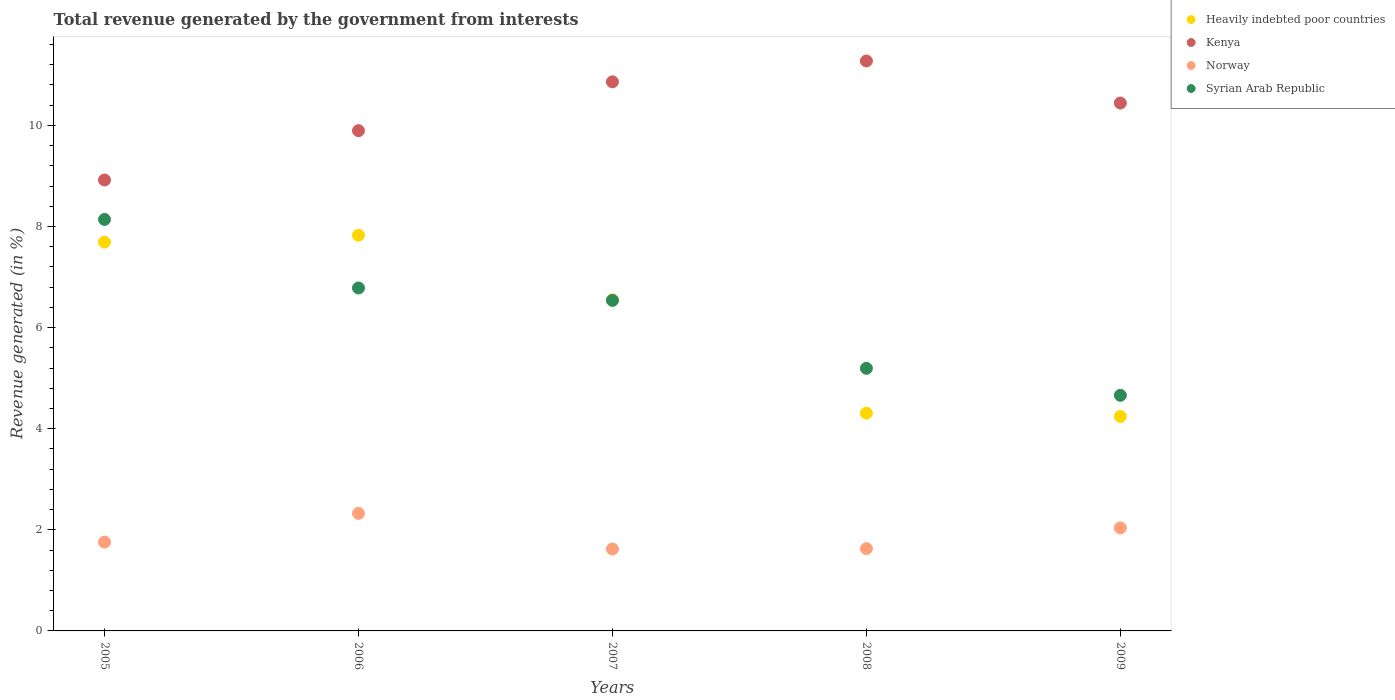How many different coloured dotlines are there?
Your response must be concise. 4. Is the number of dotlines equal to the number of legend labels?
Offer a very short reply. Yes. What is the total revenue generated in Norway in 2005?
Provide a short and direct response. 1.76. Across all years, what is the maximum total revenue generated in Heavily indebted poor countries?
Provide a succinct answer. 7.83. Across all years, what is the minimum total revenue generated in Kenya?
Your response must be concise. 8.92. What is the total total revenue generated in Kenya in the graph?
Keep it short and to the point. 51.39. What is the difference between the total revenue generated in Heavily indebted poor countries in 2007 and that in 2009?
Provide a succinct answer. 2.31. What is the difference between the total revenue generated in Syrian Arab Republic in 2005 and the total revenue generated in Norway in 2007?
Your response must be concise. 6.52. What is the average total revenue generated in Kenya per year?
Keep it short and to the point. 10.28. In the year 2009, what is the difference between the total revenue generated in Syrian Arab Republic and total revenue generated in Heavily indebted poor countries?
Make the answer very short. 0.42. What is the ratio of the total revenue generated in Kenya in 2008 to that in 2009?
Your answer should be very brief. 1.08. What is the difference between the highest and the second highest total revenue generated in Norway?
Offer a very short reply. 0.29. What is the difference between the highest and the lowest total revenue generated in Heavily indebted poor countries?
Provide a short and direct response. 3.59. Is it the case that in every year, the sum of the total revenue generated in Norway and total revenue generated in Syrian Arab Republic  is greater than the sum of total revenue generated in Kenya and total revenue generated in Heavily indebted poor countries?
Offer a terse response. No. Is it the case that in every year, the sum of the total revenue generated in Norway and total revenue generated in Kenya  is greater than the total revenue generated in Heavily indebted poor countries?
Your answer should be very brief. Yes. Is the total revenue generated in Heavily indebted poor countries strictly less than the total revenue generated in Kenya over the years?
Keep it short and to the point. Yes. How many years are there in the graph?
Your response must be concise. 5. What is the difference between two consecutive major ticks on the Y-axis?
Offer a terse response. 2. Does the graph contain any zero values?
Ensure brevity in your answer.  No. Does the graph contain grids?
Your answer should be compact. No. How many legend labels are there?
Ensure brevity in your answer.  4. What is the title of the graph?
Offer a terse response. Total revenue generated by the government from interests. Does "Algeria" appear as one of the legend labels in the graph?
Keep it short and to the point. No. What is the label or title of the Y-axis?
Provide a short and direct response. Revenue generated (in %). What is the Revenue generated (in %) of Heavily indebted poor countries in 2005?
Your answer should be very brief. 7.69. What is the Revenue generated (in %) in Kenya in 2005?
Offer a very short reply. 8.92. What is the Revenue generated (in %) of Norway in 2005?
Your answer should be compact. 1.76. What is the Revenue generated (in %) of Syrian Arab Republic in 2005?
Your answer should be compact. 8.14. What is the Revenue generated (in %) of Heavily indebted poor countries in 2006?
Offer a terse response. 7.83. What is the Revenue generated (in %) in Kenya in 2006?
Keep it short and to the point. 9.9. What is the Revenue generated (in %) of Norway in 2006?
Offer a very short reply. 2.32. What is the Revenue generated (in %) of Syrian Arab Republic in 2006?
Make the answer very short. 6.78. What is the Revenue generated (in %) of Heavily indebted poor countries in 2007?
Offer a terse response. 6.55. What is the Revenue generated (in %) of Kenya in 2007?
Make the answer very short. 10.86. What is the Revenue generated (in %) in Norway in 2007?
Ensure brevity in your answer.  1.62. What is the Revenue generated (in %) of Syrian Arab Republic in 2007?
Keep it short and to the point. 6.54. What is the Revenue generated (in %) of Heavily indebted poor countries in 2008?
Make the answer very short. 4.31. What is the Revenue generated (in %) in Kenya in 2008?
Give a very brief answer. 11.27. What is the Revenue generated (in %) of Norway in 2008?
Offer a terse response. 1.63. What is the Revenue generated (in %) in Syrian Arab Republic in 2008?
Provide a succinct answer. 5.19. What is the Revenue generated (in %) of Heavily indebted poor countries in 2009?
Provide a succinct answer. 4.24. What is the Revenue generated (in %) in Kenya in 2009?
Your response must be concise. 10.44. What is the Revenue generated (in %) in Norway in 2009?
Keep it short and to the point. 2.04. What is the Revenue generated (in %) of Syrian Arab Republic in 2009?
Keep it short and to the point. 4.66. Across all years, what is the maximum Revenue generated (in %) in Heavily indebted poor countries?
Your response must be concise. 7.83. Across all years, what is the maximum Revenue generated (in %) of Kenya?
Make the answer very short. 11.27. Across all years, what is the maximum Revenue generated (in %) of Norway?
Your answer should be compact. 2.32. Across all years, what is the maximum Revenue generated (in %) of Syrian Arab Republic?
Provide a succinct answer. 8.14. Across all years, what is the minimum Revenue generated (in %) of Heavily indebted poor countries?
Offer a terse response. 4.24. Across all years, what is the minimum Revenue generated (in %) in Kenya?
Provide a succinct answer. 8.92. Across all years, what is the minimum Revenue generated (in %) of Norway?
Make the answer very short. 1.62. Across all years, what is the minimum Revenue generated (in %) in Syrian Arab Republic?
Provide a succinct answer. 4.66. What is the total Revenue generated (in %) of Heavily indebted poor countries in the graph?
Your answer should be very brief. 30.62. What is the total Revenue generated (in %) in Kenya in the graph?
Provide a short and direct response. 51.39. What is the total Revenue generated (in %) in Norway in the graph?
Offer a terse response. 9.37. What is the total Revenue generated (in %) of Syrian Arab Republic in the graph?
Ensure brevity in your answer.  31.32. What is the difference between the Revenue generated (in %) of Heavily indebted poor countries in 2005 and that in 2006?
Provide a short and direct response. -0.14. What is the difference between the Revenue generated (in %) in Kenya in 2005 and that in 2006?
Give a very brief answer. -0.98. What is the difference between the Revenue generated (in %) of Norway in 2005 and that in 2006?
Offer a very short reply. -0.57. What is the difference between the Revenue generated (in %) of Syrian Arab Republic in 2005 and that in 2006?
Provide a succinct answer. 1.36. What is the difference between the Revenue generated (in %) of Heavily indebted poor countries in 2005 and that in 2007?
Your answer should be very brief. 1.14. What is the difference between the Revenue generated (in %) of Kenya in 2005 and that in 2007?
Keep it short and to the point. -1.94. What is the difference between the Revenue generated (in %) of Norway in 2005 and that in 2007?
Your answer should be very brief. 0.14. What is the difference between the Revenue generated (in %) of Syrian Arab Republic in 2005 and that in 2007?
Your answer should be very brief. 1.6. What is the difference between the Revenue generated (in %) of Heavily indebted poor countries in 2005 and that in 2008?
Your response must be concise. 3.38. What is the difference between the Revenue generated (in %) in Kenya in 2005 and that in 2008?
Your answer should be compact. -2.35. What is the difference between the Revenue generated (in %) of Norway in 2005 and that in 2008?
Keep it short and to the point. 0.13. What is the difference between the Revenue generated (in %) in Syrian Arab Republic in 2005 and that in 2008?
Give a very brief answer. 2.94. What is the difference between the Revenue generated (in %) of Heavily indebted poor countries in 2005 and that in 2009?
Your answer should be very brief. 3.45. What is the difference between the Revenue generated (in %) of Kenya in 2005 and that in 2009?
Provide a short and direct response. -1.52. What is the difference between the Revenue generated (in %) of Norway in 2005 and that in 2009?
Offer a terse response. -0.28. What is the difference between the Revenue generated (in %) in Syrian Arab Republic in 2005 and that in 2009?
Your answer should be very brief. 3.48. What is the difference between the Revenue generated (in %) in Heavily indebted poor countries in 2006 and that in 2007?
Your answer should be compact. 1.28. What is the difference between the Revenue generated (in %) in Kenya in 2006 and that in 2007?
Give a very brief answer. -0.97. What is the difference between the Revenue generated (in %) in Norway in 2006 and that in 2007?
Give a very brief answer. 0.7. What is the difference between the Revenue generated (in %) of Syrian Arab Republic in 2006 and that in 2007?
Provide a succinct answer. 0.25. What is the difference between the Revenue generated (in %) of Heavily indebted poor countries in 2006 and that in 2008?
Your response must be concise. 3.52. What is the difference between the Revenue generated (in %) of Kenya in 2006 and that in 2008?
Give a very brief answer. -1.38. What is the difference between the Revenue generated (in %) in Norway in 2006 and that in 2008?
Give a very brief answer. 0.7. What is the difference between the Revenue generated (in %) in Syrian Arab Republic in 2006 and that in 2008?
Your response must be concise. 1.59. What is the difference between the Revenue generated (in %) in Heavily indebted poor countries in 2006 and that in 2009?
Offer a terse response. 3.59. What is the difference between the Revenue generated (in %) of Kenya in 2006 and that in 2009?
Provide a short and direct response. -0.55. What is the difference between the Revenue generated (in %) in Norway in 2006 and that in 2009?
Give a very brief answer. 0.29. What is the difference between the Revenue generated (in %) in Syrian Arab Republic in 2006 and that in 2009?
Your answer should be compact. 2.12. What is the difference between the Revenue generated (in %) in Heavily indebted poor countries in 2007 and that in 2008?
Provide a succinct answer. 2.24. What is the difference between the Revenue generated (in %) of Kenya in 2007 and that in 2008?
Offer a very short reply. -0.41. What is the difference between the Revenue generated (in %) of Norway in 2007 and that in 2008?
Provide a short and direct response. -0.01. What is the difference between the Revenue generated (in %) in Syrian Arab Republic in 2007 and that in 2008?
Ensure brevity in your answer.  1.34. What is the difference between the Revenue generated (in %) of Heavily indebted poor countries in 2007 and that in 2009?
Give a very brief answer. 2.31. What is the difference between the Revenue generated (in %) of Kenya in 2007 and that in 2009?
Your answer should be compact. 0.42. What is the difference between the Revenue generated (in %) of Norway in 2007 and that in 2009?
Your response must be concise. -0.42. What is the difference between the Revenue generated (in %) in Syrian Arab Republic in 2007 and that in 2009?
Offer a very short reply. 1.88. What is the difference between the Revenue generated (in %) of Heavily indebted poor countries in 2008 and that in 2009?
Ensure brevity in your answer.  0.07. What is the difference between the Revenue generated (in %) of Kenya in 2008 and that in 2009?
Offer a terse response. 0.83. What is the difference between the Revenue generated (in %) in Norway in 2008 and that in 2009?
Offer a terse response. -0.41. What is the difference between the Revenue generated (in %) of Syrian Arab Republic in 2008 and that in 2009?
Offer a very short reply. 0.53. What is the difference between the Revenue generated (in %) in Heavily indebted poor countries in 2005 and the Revenue generated (in %) in Kenya in 2006?
Your answer should be compact. -2.2. What is the difference between the Revenue generated (in %) of Heavily indebted poor countries in 2005 and the Revenue generated (in %) of Norway in 2006?
Offer a terse response. 5.37. What is the difference between the Revenue generated (in %) in Heavily indebted poor countries in 2005 and the Revenue generated (in %) in Syrian Arab Republic in 2006?
Offer a terse response. 0.91. What is the difference between the Revenue generated (in %) of Kenya in 2005 and the Revenue generated (in %) of Norway in 2006?
Provide a succinct answer. 6.59. What is the difference between the Revenue generated (in %) of Kenya in 2005 and the Revenue generated (in %) of Syrian Arab Republic in 2006?
Provide a short and direct response. 2.14. What is the difference between the Revenue generated (in %) of Norway in 2005 and the Revenue generated (in %) of Syrian Arab Republic in 2006?
Give a very brief answer. -5.03. What is the difference between the Revenue generated (in %) in Heavily indebted poor countries in 2005 and the Revenue generated (in %) in Kenya in 2007?
Ensure brevity in your answer.  -3.17. What is the difference between the Revenue generated (in %) in Heavily indebted poor countries in 2005 and the Revenue generated (in %) in Norway in 2007?
Provide a short and direct response. 6.07. What is the difference between the Revenue generated (in %) of Heavily indebted poor countries in 2005 and the Revenue generated (in %) of Syrian Arab Republic in 2007?
Ensure brevity in your answer.  1.15. What is the difference between the Revenue generated (in %) in Kenya in 2005 and the Revenue generated (in %) in Norway in 2007?
Give a very brief answer. 7.3. What is the difference between the Revenue generated (in %) of Kenya in 2005 and the Revenue generated (in %) of Syrian Arab Republic in 2007?
Give a very brief answer. 2.38. What is the difference between the Revenue generated (in %) in Norway in 2005 and the Revenue generated (in %) in Syrian Arab Republic in 2007?
Offer a terse response. -4.78. What is the difference between the Revenue generated (in %) of Heavily indebted poor countries in 2005 and the Revenue generated (in %) of Kenya in 2008?
Keep it short and to the point. -3.58. What is the difference between the Revenue generated (in %) of Heavily indebted poor countries in 2005 and the Revenue generated (in %) of Norway in 2008?
Your answer should be very brief. 6.06. What is the difference between the Revenue generated (in %) of Heavily indebted poor countries in 2005 and the Revenue generated (in %) of Syrian Arab Republic in 2008?
Offer a terse response. 2.5. What is the difference between the Revenue generated (in %) in Kenya in 2005 and the Revenue generated (in %) in Norway in 2008?
Give a very brief answer. 7.29. What is the difference between the Revenue generated (in %) of Kenya in 2005 and the Revenue generated (in %) of Syrian Arab Republic in 2008?
Offer a very short reply. 3.73. What is the difference between the Revenue generated (in %) in Norway in 2005 and the Revenue generated (in %) in Syrian Arab Republic in 2008?
Make the answer very short. -3.44. What is the difference between the Revenue generated (in %) in Heavily indebted poor countries in 2005 and the Revenue generated (in %) in Kenya in 2009?
Offer a terse response. -2.75. What is the difference between the Revenue generated (in %) in Heavily indebted poor countries in 2005 and the Revenue generated (in %) in Norway in 2009?
Your response must be concise. 5.65. What is the difference between the Revenue generated (in %) of Heavily indebted poor countries in 2005 and the Revenue generated (in %) of Syrian Arab Republic in 2009?
Offer a terse response. 3.03. What is the difference between the Revenue generated (in %) in Kenya in 2005 and the Revenue generated (in %) in Norway in 2009?
Your response must be concise. 6.88. What is the difference between the Revenue generated (in %) in Kenya in 2005 and the Revenue generated (in %) in Syrian Arab Republic in 2009?
Keep it short and to the point. 4.26. What is the difference between the Revenue generated (in %) in Norway in 2005 and the Revenue generated (in %) in Syrian Arab Republic in 2009?
Make the answer very short. -2.9. What is the difference between the Revenue generated (in %) in Heavily indebted poor countries in 2006 and the Revenue generated (in %) in Kenya in 2007?
Give a very brief answer. -3.03. What is the difference between the Revenue generated (in %) in Heavily indebted poor countries in 2006 and the Revenue generated (in %) in Norway in 2007?
Your response must be concise. 6.21. What is the difference between the Revenue generated (in %) of Heavily indebted poor countries in 2006 and the Revenue generated (in %) of Syrian Arab Republic in 2007?
Your answer should be very brief. 1.29. What is the difference between the Revenue generated (in %) in Kenya in 2006 and the Revenue generated (in %) in Norway in 2007?
Your answer should be very brief. 8.27. What is the difference between the Revenue generated (in %) in Kenya in 2006 and the Revenue generated (in %) in Syrian Arab Republic in 2007?
Give a very brief answer. 3.36. What is the difference between the Revenue generated (in %) in Norway in 2006 and the Revenue generated (in %) in Syrian Arab Republic in 2007?
Offer a terse response. -4.21. What is the difference between the Revenue generated (in %) of Heavily indebted poor countries in 2006 and the Revenue generated (in %) of Kenya in 2008?
Ensure brevity in your answer.  -3.45. What is the difference between the Revenue generated (in %) in Heavily indebted poor countries in 2006 and the Revenue generated (in %) in Norway in 2008?
Give a very brief answer. 6.2. What is the difference between the Revenue generated (in %) of Heavily indebted poor countries in 2006 and the Revenue generated (in %) of Syrian Arab Republic in 2008?
Give a very brief answer. 2.63. What is the difference between the Revenue generated (in %) in Kenya in 2006 and the Revenue generated (in %) in Norway in 2008?
Keep it short and to the point. 8.27. What is the difference between the Revenue generated (in %) of Kenya in 2006 and the Revenue generated (in %) of Syrian Arab Republic in 2008?
Keep it short and to the point. 4.7. What is the difference between the Revenue generated (in %) in Norway in 2006 and the Revenue generated (in %) in Syrian Arab Republic in 2008?
Offer a terse response. -2.87. What is the difference between the Revenue generated (in %) in Heavily indebted poor countries in 2006 and the Revenue generated (in %) in Kenya in 2009?
Your answer should be compact. -2.62. What is the difference between the Revenue generated (in %) of Heavily indebted poor countries in 2006 and the Revenue generated (in %) of Norway in 2009?
Offer a terse response. 5.79. What is the difference between the Revenue generated (in %) in Heavily indebted poor countries in 2006 and the Revenue generated (in %) in Syrian Arab Republic in 2009?
Offer a terse response. 3.17. What is the difference between the Revenue generated (in %) of Kenya in 2006 and the Revenue generated (in %) of Norway in 2009?
Offer a terse response. 7.86. What is the difference between the Revenue generated (in %) in Kenya in 2006 and the Revenue generated (in %) in Syrian Arab Republic in 2009?
Your answer should be very brief. 5.24. What is the difference between the Revenue generated (in %) in Norway in 2006 and the Revenue generated (in %) in Syrian Arab Republic in 2009?
Offer a very short reply. -2.34. What is the difference between the Revenue generated (in %) in Heavily indebted poor countries in 2007 and the Revenue generated (in %) in Kenya in 2008?
Provide a succinct answer. -4.73. What is the difference between the Revenue generated (in %) of Heavily indebted poor countries in 2007 and the Revenue generated (in %) of Norway in 2008?
Make the answer very short. 4.92. What is the difference between the Revenue generated (in %) of Heavily indebted poor countries in 2007 and the Revenue generated (in %) of Syrian Arab Republic in 2008?
Provide a succinct answer. 1.35. What is the difference between the Revenue generated (in %) in Kenya in 2007 and the Revenue generated (in %) in Norway in 2008?
Your answer should be very brief. 9.23. What is the difference between the Revenue generated (in %) of Kenya in 2007 and the Revenue generated (in %) of Syrian Arab Republic in 2008?
Give a very brief answer. 5.67. What is the difference between the Revenue generated (in %) of Norway in 2007 and the Revenue generated (in %) of Syrian Arab Republic in 2008?
Ensure brevity in your answer.  -3.57. What is the difference between the Revenue generated (in %) of Heavily indebted poor countries in 2007 and the Revenue generated (in %) of Kenya in 2009?
Your answer should be very brief. -3.89. What is the difference between the Revenue generated (in %) of Heavily indebted poor countries in 2007 and the Revenue generated (in %) of Norway in 2009?
Make the answer very short. 4.51. What is the difference between the Revenue generated (in %) of Heavily indebted poor countries in 2007 and the Revenue generated (in %) of Syrian Arab Republic in 2009?
Provide a succinct answer. 1.89. What is the difference between the Revenue generated (in %) of Kenya in 2007 and the Revenue generated (in %) of Norway in 2009?
Ensure brevity in your answer.  8.82. What is the difference between the Revenue generated (in %) in Kenya in 2007 and the Revenue generated (in %) in Syrian Arab Republic in 2009?
Keep it short and to the point. 6.2. What is the difference between the Revenue generated (in %) of Norway in 2007 and the Revenue generated (in %) of Syrian Arab Republic in 2009?
Offer a very short reply. -3.04. What is the difference between the Revenue generated (in %) in Heavily indebted poor countries in 2008 and the Revenue generated (in %) in Kenya in 2009?
Your answer should be very brief. -6.14. What is the difference between the Revenue generated (in %) of Heavily indebted poor countries in 2008 and the Revenue generated (in %) of Norway in 2009?
Make the answer very short. 2.27. What is the difference between the Revenue generated (in %) of Heavily indebted poor countries in 2008 and the Revenue generated (in %) of Syrian Arab Republic in 2009?
Your answer should be compact. -0.35. What is the difference between the Revenue generated (in %) in Kenya in 2008 and the Revenue generated (in %) in Norway in 2009?
Your answer should be compact. 9.24. What is the difference between the Revenue generated (in %) in Kenya in 2008 and the Revenue generated (in %) in Syrian Arab Republic in 2009?
Offer a terse response. 6.61. What is the difference between the Revenue generated (in %) in Norway in 2008 and the Revenue generated (in %) in Syrian Arab Republic in 2009?
Keep it short and to the point. -3.03. What is the average Revenue generated (in %) of Heavily indebted poor countries per year?
Give a very brief answer. 6.12. What is the average Revenue generated (in %) in Kenya per year?
Give a very brief answer. 10.28. What is the average Revenue generated (in %) in Norway per year?
Your answer should be very brief. 1.87. What is the average Revenue generated (in %) in Syrian Arab Republic per year?
Keep it short and to the point. 6.26. In the year 2005, what is the difference between the Revenue generated (in %) of Heavily indebted poor countries and Revenue generated (in %) of Kenya?
Make the answer very short. -1.23. In the year 2005, what is the difference between the Revenue generated (in %) of Heavily indebted poor countries and Revenue generated (in %) of Norway?
Your answer should be very brief. 5.93. In the year 2005, what is the difference between the Revenue generated (in %) of Heavily indebted poor countries and Revenue generated (in %) of Syrian Arab Republic?
Provide a short and direct response. -0.45. In the year 2005, what is the difference between the Revenue generated (in %) in Kenya and Revenue generated (in %) in Norway?
Offer a very short reply. 7.16. In the year 2005, what is the difference between the Revenue generated (in %) in Kenya and Revenue generated (in %) in Syrian Arab Republic?
Your response must be concise. 0.78. In the year 2005, what is the difference between the Revenue generated (in %) of Norway and Revenue generated (in %) of Syrian Arab Republic?
Your answer should be very brief. -6.38. In the year 2006, what is the difference between the Revenue generated (in %) of Heavily indebted poor countries and Revenue generated (in %) of Kenya?
Give a very brief answer. -2.07. In the year 2006, what is the difference between the Revenue generated (in %) of Heavily indebted poor countries and Revenue generated (in %) of Norway?
Your response must be concise. 5.5. In the year 2006, what is the difference between the Revenue generated (in %) in Heavily indebted poor countries and Revenue generated (in %) in Syrian Arab Republic?
Ensure brevity in your answer.  1.04. In the year 2006, what is the difference between the Revenue generated (in %) of Kenya and Revenue generated (in %) of Norway?
Your answer should be compact. 7.57. In the year 2006, what is the difference between the Revenue generated (in %) in Kenya and Revenue generated (in %) in Syrian Arab Republic?
Offer a terse response. 3.11. In the year 2006, what is the difference between the Revenue generated (in %) of Norway and Revenue generated (in %) of Syrian Arab Republic?
Offer a very short reply. -4.46. In the year 2007, what is the difference between the Revenue generated (in %) of Heavily indebted poor countries and Revenue generated (in %) of Kenya?
Offer a very short reply. -4.31. In the year 2007, what is the difference between the Revenue generated (in %) of Heavily indebted poor countries and Revenue generated (in %) of Norway?
Your answer should be very brief. 4.93. In the year 2007, what is the difference between the Revenue generated (in %) in Heavily indebted poor countries and Revenue generated (in %) in Syrian Arab Republic?
Your answer should be very brief. 0.01. In the year 2007, what is the difference between the Revenue generated (in %) of Kenya and Revenue generated (in %) of Norway?
Make the answer very short. 9.24. In the year 2007, what is the difference between the Revenue generated (in %) in Kenya and Revenue generated (in %) in Syrian Arab Republic?
Ensure brevity in your answer.  4.32. In the year 2007, what is the difference between the Revenue generated (in %) in Norway and Revenue generated (in %) in Syrian Arab Republic?
Offer a terse response. -4.92. In the year 2008, what is the difference between the Revenue generated (in %) of Heavily indebted poor countries and Revenue generated (in %) of Kenya?
Provide a succinct answer. -6.97. In the year 2008, what is the difference between the Revenue generated (in %) in Heavily indebted poor countries and Revenue generated (in %) in Norway?
Make the answer very short. 2.68. In the year 2008, what is the difference between the Revenue generated (in %) in Heavily indebted poor countries and Revenue generated (in %) in Syrian Arab Republic?
Ensure brevity in your answer.  -0.89. In the year 2008, what is the difference between the Revenue generated (in %) in Kenya and Revenue generated (in %) in Norway?
Your answer should be compact. 9.65. In the year 2008, what is the difference between the Revenue generated (in %) of Kenya and Revenue generated (in %) of Syrian Arab Republic?
Ensure brevity in your answer.  6.08. In the year 2008, what is the difference between the Revenue generated (in %) in Norway and Revenue generated (in %) in Syrian Arab Republic?
Give a very brief answer. -3.57. In the year 2009, what is the difference between the Revenue generated (in %) of Heavily indebted poor countries and Revenue generated (in %) of Kenya?
Offer a terse response. -6.2. In the year 2009, what is the difference between the Revenue generated (in %) of Heavily indebted poor countries and Revenue generated (in %) of Norway?
Make the answer very short. 2.2. In the year 2009, what is the difference between the Revenue generated (in %) in Heavily indebted poor countries and Revenue generated (in %) in Syrian Arab Republic?
Keep it short and to the point. -0.42. In the year 2009, what is the difference between the Revenue generated (in %) of Kenya and Revenue generated (in %) of Norway?
Make the answer very short. 8.4. In the year 2009, what is the difference between the Revenue generated (in %) in Kenya and Revenue generated (in %) in Syrian Arab Republic?
Provide a succinct answer. 5.78. In the year 2009, what is the difference between the Revenue generated (in %) of Norway and Revenue generated (in %) of Syrian Arab Republic?
Offer a terse response. -2.62. What is the ratio of the Revenue generated (in %) of Heavily indebted poor countries in 2005 to that in 2006?
Provide a short and direct response. 0.98. What is the ratio of the Revenue generated (in %) in Kenya in 2005 to that in 2006?
Provide a succinct answer. 0.9. What is the ratio of the Revenue generated (in %) in Norway in 2005 to that in 2006?
Provide a short and direct response. 0.76. What is the ratio of the Revenue generated (in %) in Syrian Arab Republic in 2005 to that in 2006?
Ensure brevity in your answer.  1.2. What is the ratio of the Revenue generated (in %) of Heavily indebted poor countries in 2005 to that in 2007?
Ensure brevity in your answer.  1.17. What is the ratio of the Revenue generated (in %) in Kenya in 2005 to that in 2007?
Make the answer very short. 0.82. What is the ratio of the Revenue generated (in %) in Norway in 2005 to that in 2007?
Keep it short and to the point. 1.08. What is the ratio of the Revenue generated (in %) of Syrian Arab Republic in 2005 to that in 2007?
Offer a very short reply. 1.24. What is the ratio of the Revenue generated (in %) in Heavily indebted poor countries in 2005 to that in 2008?
Make the answer very short. 1.79. What is the ratio of the Revenue generated (in %) in Kenya in 2005 to that in 2008?
Offer a terse response. 0.79. What is the ratio of the Revenue generated (in %) of Norway in 2005 to that in 2008?
Your answer should be compact. 1.08. What is the ratio of the Revenue generated (in %) in Syrian Arab Republic in 2005 to that in 2008?
Provide a short and direct response. 1.57. What is the ratio of the Revenue generated (in %) of Heavily indebted poor countries in 2005 to that in 2009?
Keep it short and to the point. 1.81. What is the ratio of the Revenue generated (in %) of Kenya in 2005 to that in 2009?
Your answer should be compact. 0.85. What is the ratio of the Revenue generated (in %) in Norway in 2005 to that in 2009?
Offer a terse response. 0.86. What is the ratio of the Revenue generated (in %) in Syrian Arab Republic in 2005 to that in 2009?
Make the answer very short. 1.75. What is the ratio of the Revenue generated (in %) of Heavily indebted poor countries in 2006 to that in 2007?
Keep it short and to the point. 1.2. What is the ratio of the Revenue generated (in %) of Kenya in 2006 to that in 2007?
Give a very brief answer. 0.91. What is the ratio of the Revenue generated (in %) of Norway in 2006 to that in 2007?
Offer a terse response. 1.43. What is the ratio of the Revenue generated (in %) of Syrian Arab Republic in 2006 to that in 2007?
Your answer should be very brief. 1.04. What is the ratio of the Revenue generated (in %) in Heavily indebted poor countries in 2006 to that in 2008?
Offer a very short reply. 1.82. What is the ratio of the Revenue generated (in %) of Kenya in 2006 to that in 2008?
Offer a terse response. 0.88. What is the ratio of the Revenue generated (in %) of Norway in 2006 to that in 2008?
Your answer should be compact. 1.43. What is the ratio of the Revenue generated (in %) in Syrian Arab Republic in 2006 to that in 2008?
Your answer should be very brief. 1.31. What is the ratio of the Revenue generated (in %) of Heavily indebted poor countries in 2006 to that in 2009?
Provide a short and direct response. 1.85. What is the ratio of the Revenue generated (in %) of Kenya in 2006 to that in 2009?
Your answer should be very brief. 0.95. What is the ratio of the Revenue generated (in %) in Norway in 2006 to that in 2009?
Make the answer very short. 1.14. What is the ratio of the Revenue generated (in %) of Syrian Arab Republic in 2006 to that in 2009?
Your response must be concise. 1.46. What is the ratio of the Revenue generated (in %) of Heavily indebted poor countries in 2007 to that in 2008?
Offer a terse response. 1.52. What is the ratio of the Revenue generated (in %) in Kenya in 2007 to that in 2008?
Ensure brevity in your answer.  0.96. What is the ratio of the Revenue generated (in %) in Norway in 2007 to that in 2008?
Give a very brief answer. 1. What is the ratio of the Revenue generated (in %) of Syrian Arab Republic in 2007 to that in 2008?
Offer a very short reply. 1.26. What is the ratio of the Revenue generated (in %) of Heavily indebted poor countries in 2007 to that in 2009?
Provide a succinct answer. 1.54. What is the ratio of the Revenue generated (in %) in Kenya in 2007 to that in 2009?
Provide a succinct answer. 1.04. What is the ratio of the Revenue generated (in %) in Norway in 2007 to that in 2009?
Your answer should be compact. 0.8. What is the ratio of the Revenue generated (in %) in Syrian Arab Republic in 2007 to that in 2009?
Your answer should be compact. 1.4. What is the ratio of the Revenue generated (in %) in Heavily indebted poor countries in 2008 to that in 2009?
Provide a short and direct response. 1.02. What is the ratio of the Revenue generated (in %) of Kenya in 2008 to that in 2009?
Keep it short and to the point. 1.08. What is the ratio of the Revenue generated (in %) in Norway in 2008 to that in 2009?
Offer a terse response. 0.8. What is the ratio of the Revenue generated (in %) in Syrian Arab Republic in 2008 to that in 2009?
Keep it short and to the point. 1.11. What is the difference between the highest and the second highest Revenue generated (in %) of Heavily indebted poor countries?
Keep it short and to the point. 0.14. What is the difference between the highest and the second highest Revenue generated (in %) of Kenya?
Make the answer very short. 0.41. What is the difference between the highest and the second highest Revenue generated (in %) of Norway?
Offer a terse response. 0.29. What is the difference between the highest and the second highest Revenue generated (in %) of Syrian Arab Republic?
Your answer should be compact. 1.36. What is the difference between the highest and the lowest Revenue generated (in %) of Heavily indebted poor countries?
Offer a terse response. 3.59. What is the difference between the highest and the lowest Revenue generated (in %) in Kenya?
Offer a very short reply. 2.35. What is the difference between the highest and the lowest Revenue generated (in %) in Norway?
Ensure brevity in your answer.  0.7. What is the difference between the highest and the lowest Revenue generated (in %) of Syrian Arab Republic?
Keep it short and to the point. 3.48. 